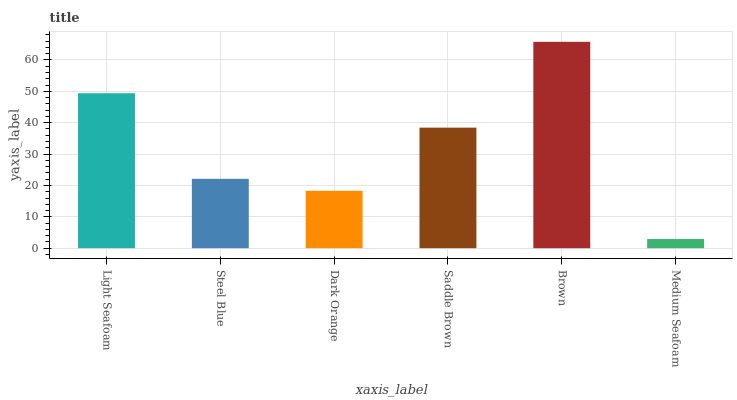Is Medium Seafoam the minimum?
Answer yes or no. Yes. Is Brown the maximum?
Answer yes or no. Yes. Is Steel Blue the minimum?
Answer yes or no. No. Is Steel Blue the maximum?
Answer yes or no. No. Is Light Seafoam greater than Steel Blue?
Answer yes or no. Yes. Is Steel Blue less than Light Seafoam?
Answer yes or no. Yes. Is Steel Blue greater than Light Seafoam?
Answer yes or no. No. Is Light Seafoam less than Steel Blue?
Answer yes or no. No. Is Saddle Brown the high median?
Answer yes or no. Yes. Is Steel Blue the low median?
Answer yes or no. Yes. Is Light Seafoam the high median?
Answer yes or no. No. Is Dark Orange the low median?
Answer yes or no. No. 